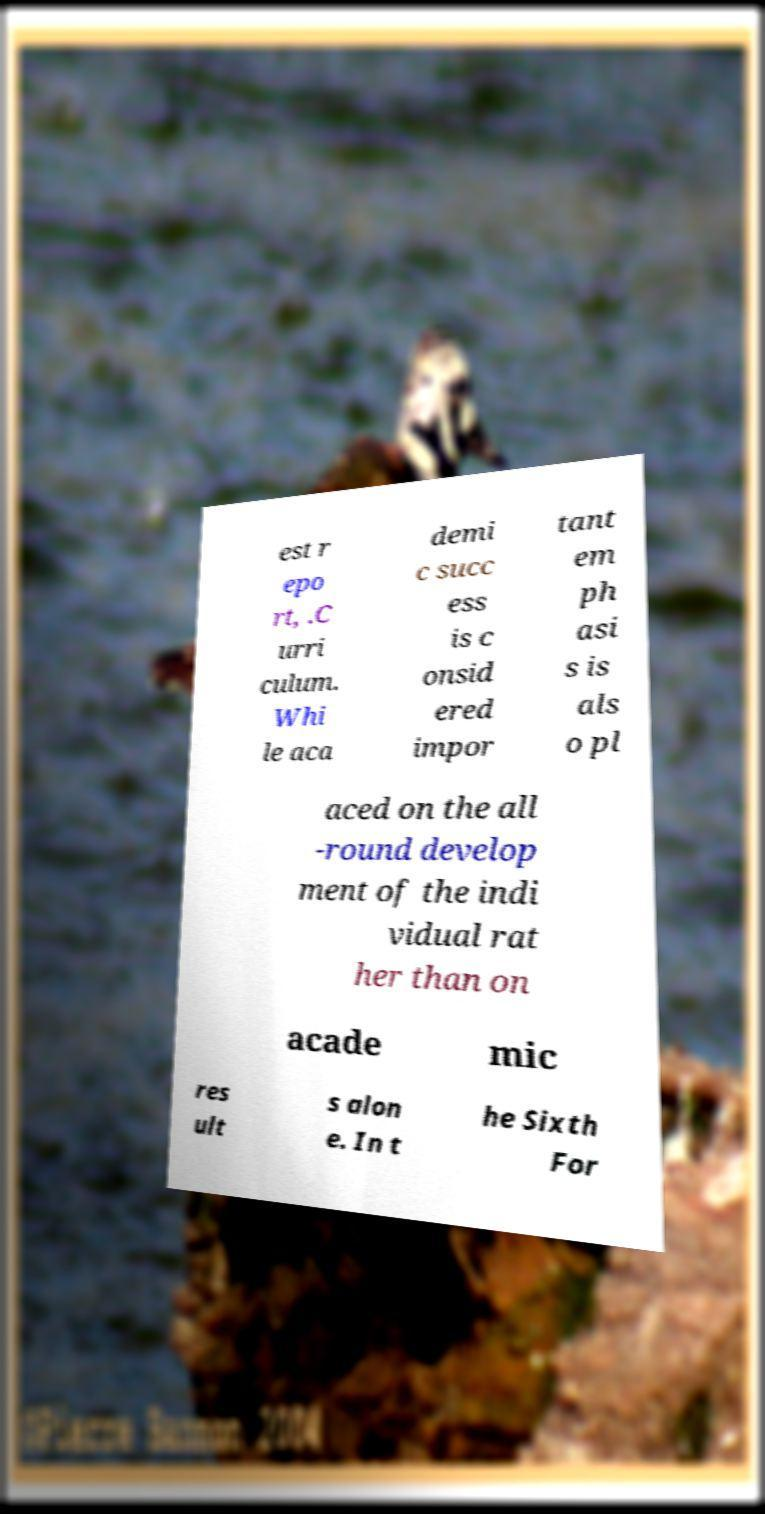Can you accurately transcribe the text from the provided image for me? est r epo rt, .C urri culum. Whi le aca demi c succ ess is c onsid ered impor tant em ph asi s is als o pl aced on the all -round develop ment of the indi vidual rat her than on acade mic res ult s alon e. In t he Sixth For 